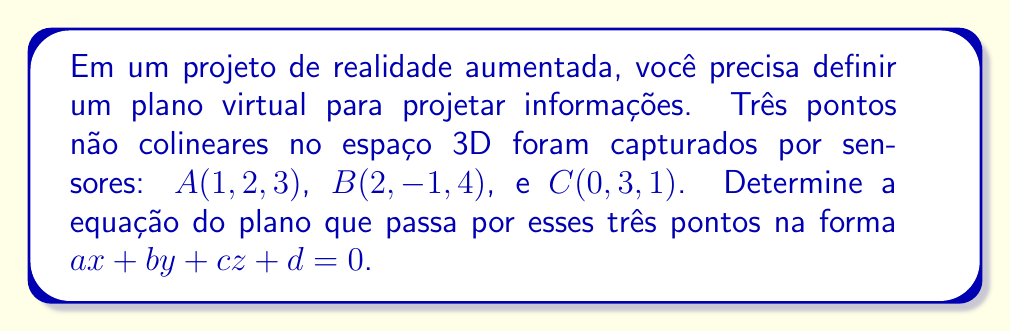Could you help me with this problem? Para encontrar a equação do plano, seguiremos estes passos:

1) Primeiro, calculamos dois vetores no plano:
   $\vec{AB} = B - A = (1, -3, 1)$
   $\vec{AC} = C - A = (-1, 1, -2)$

2) O vetor normal ao plano é o produto vetorial desses dois vetores:
   $\vec{n} = \vec{AB} \times \vec{AC}$

   $$\vec{n} = \begin{vmatrix}
   i & j & k \\
   1 & -3 & 1 \\
   -1 & 1 & -2
   \end{vmatrix}$$

   $\vec{n} = ((-3)(-2) - (1)(1))i - ((1)(-2) - (1)(-1))j + ((1)(1) - (-3)(-1))k$
   
   $\vec{n} = (5)i - (-3)j + (-2)k = (5, 3, -2)$

3) A equação do plano tem a forma $ax + by + cz + d = 0$, onde $(a, b, c)$ é o vetor normal.

4) Substituímos um ponto conhecido (por exemplo, A(1, 2, 3)) na equação:

   $5(1) + 3(2) + (-2)(3) + d = 0$
   $5 + 6 - 6 + d = 0$
   $d = -5$

5) Portanto, a equação do plano é:

   $5x + 3y - 2z - 5 = 0$
Answer: $5x + 3y - 2z - 5 = 0$ 